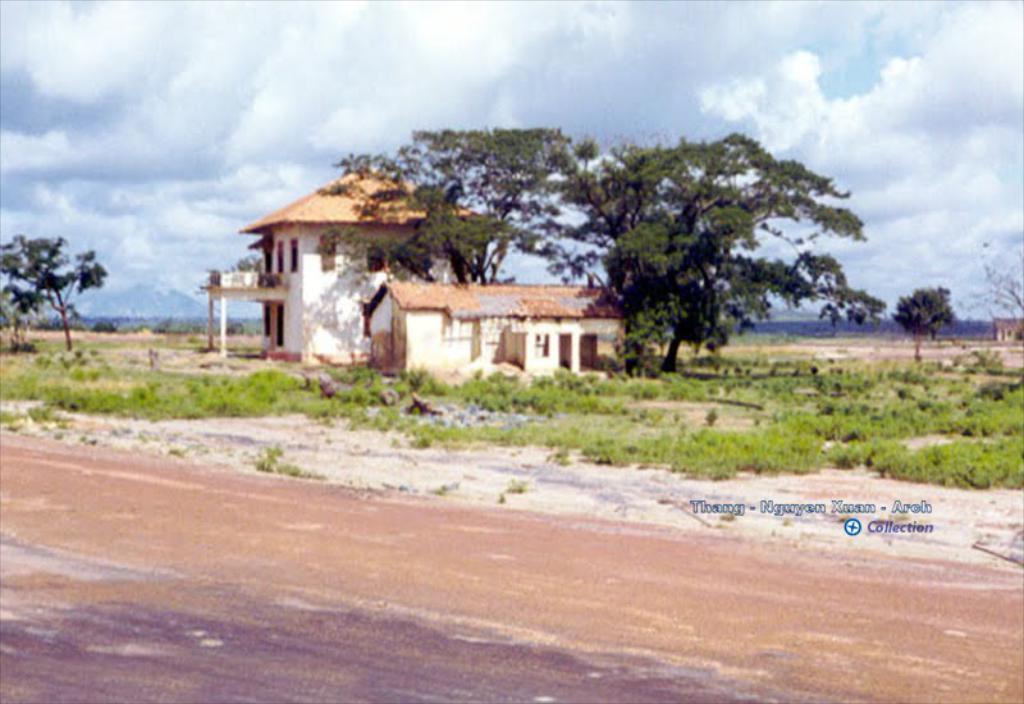Can you describe this image briefly? At the bottom we can see ground. In the background there are plants,trees,two houses,windows,mountains and clouds in the sky. On the right we can see a house. 